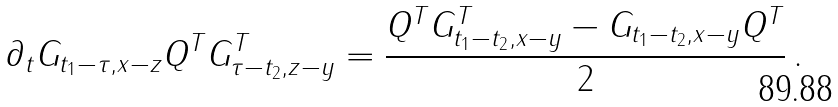<formula> <loc_0><loc_0><loc_500><loc_500>\partial _ { t } G _ { t _ { 1 } - \tau , x - z } Q ^ { T } G ^ { T } _ { \tau - t _ { 2 } , z - y } = \frac { Q ^ { T } G ^ { T } _ { t _ { 1 } - t _ { 2 } , x - y } - G _ { t _ { 1 } - t _ { 2 } , x - y } Q ^ { T } } { 2 } \, .</formula> 